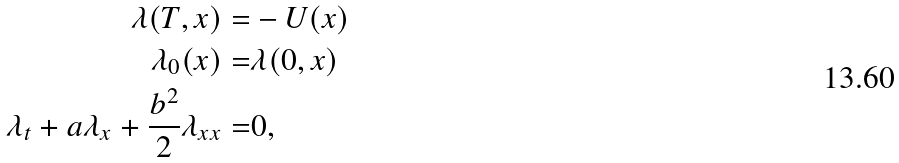Convert formula to latex. <formula><loc_0><loc_0><loc_500><loc_500>\lambda ( T , x ) = & - U ( x ) \\ \lambda _ { 0 } ( x ) = & \lambda ( 0 , x ) \\ \lambda _ { t } + a \lambda _ { x } + \frac { b ^ { 2 } } { 2 } \lambda _ { x x } = & 0 ,</formula> 